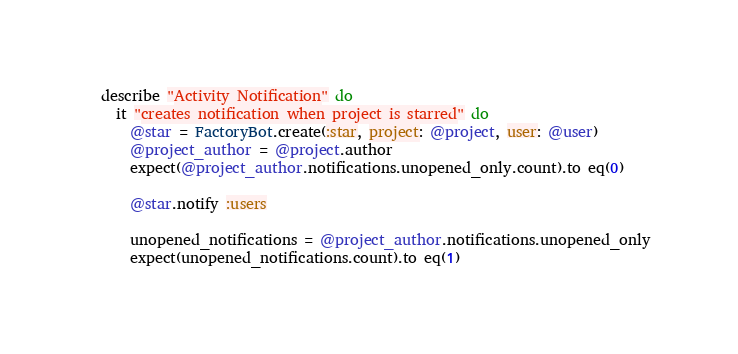Convert code to text. <code><loc_0><loc_0><loc_500><loc_500><_Ruby_>
  describe "Activity Notification" do
    it "creates notification when project is starred" do
      @star = FactoryBot.create(:star, project: @project, user: @user)
      @project_author = @project.author
      expect(@project_author.notifications.unopened_only.count).to eq(0)

      @star.notify :users

      unopened_notifications = @project_author.notifications.unopened_only
      expect(unopened_notifications.count).to eq(1)</code> 